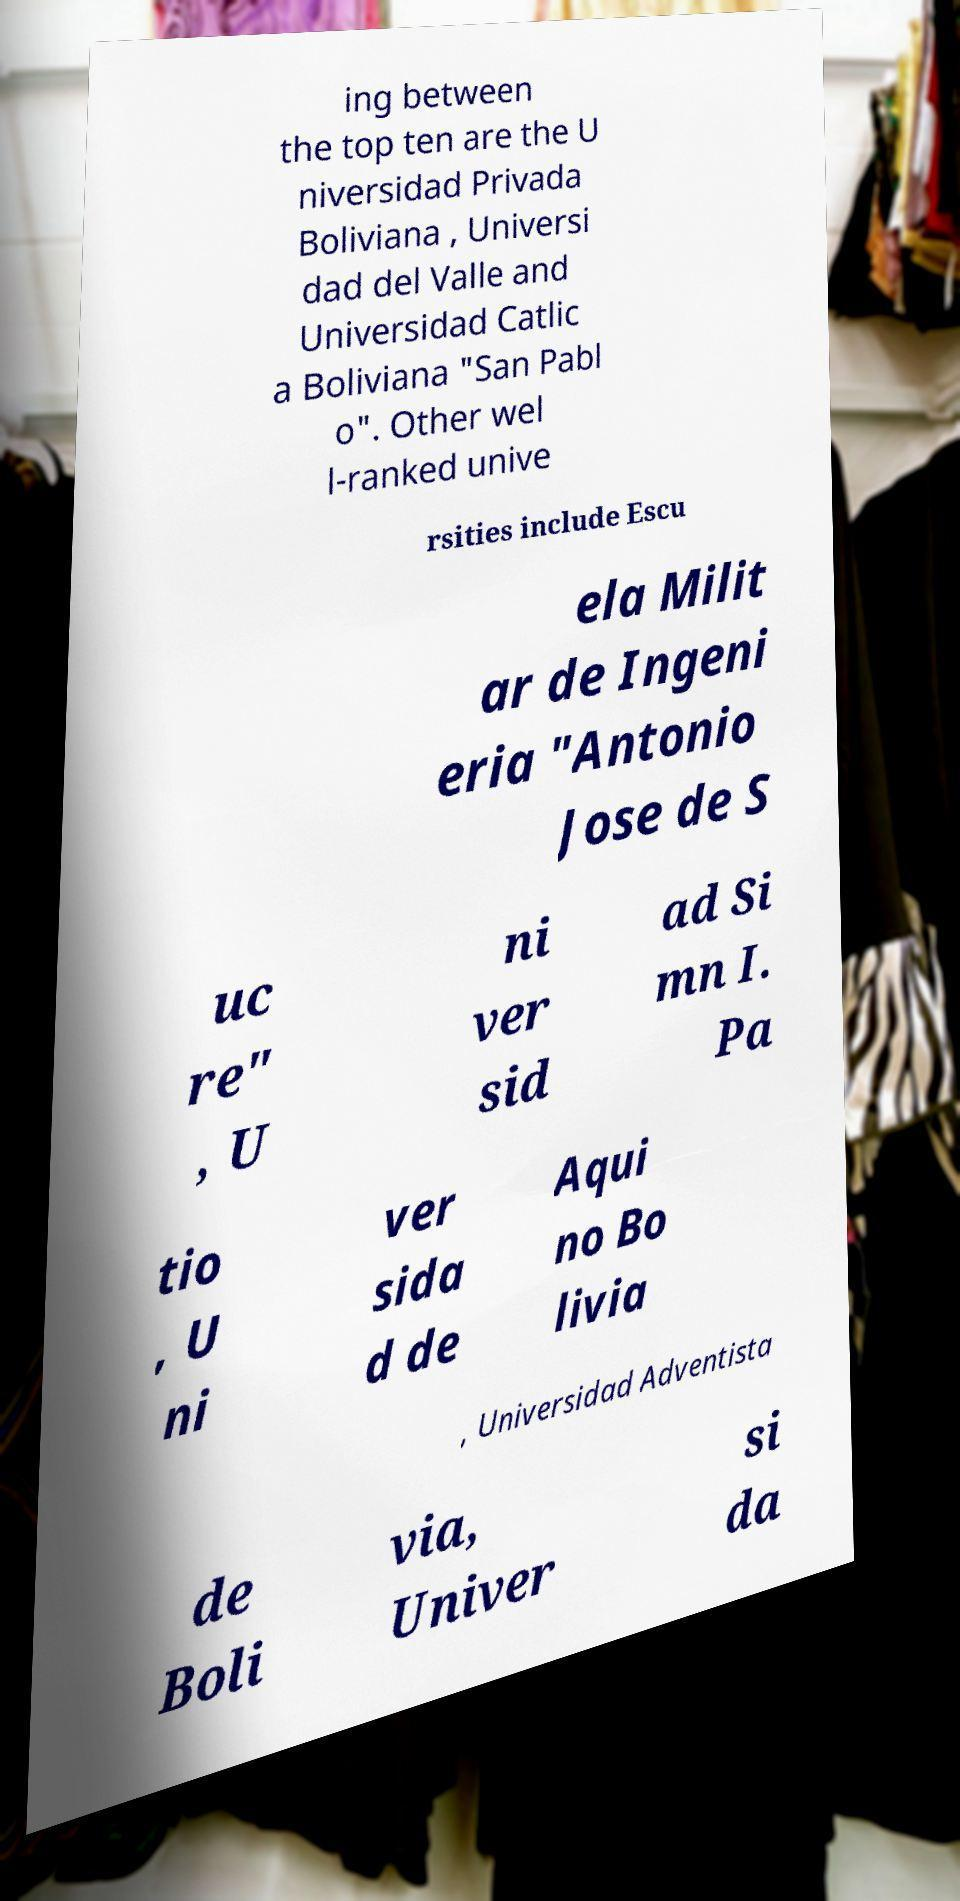Could you assist in decoding the text presented in this image and type it out clearly? ing between the top ten are the U niversidad Privada Boliviana , Universi dad del Valle and Universidad Catlic a Boliviana "San Pabl o". Other wel l-ranked unive rsities include Escu ela Milit ar de Ingeni eria "Antonio Jose de S uc re" , U ni ver sid ad Si mn I. Pa tio , U ni ver sida d de Aqui no Bo livia , Universidad Adventista de Boli via, Univer si da 